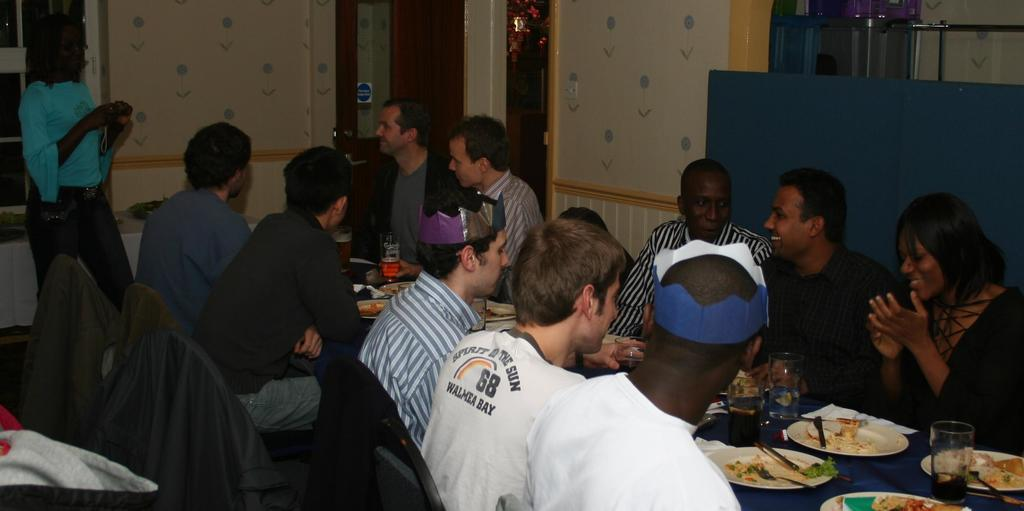<image>
Present a compact description of the photo's key features. A man in a white shirt with the number 68 